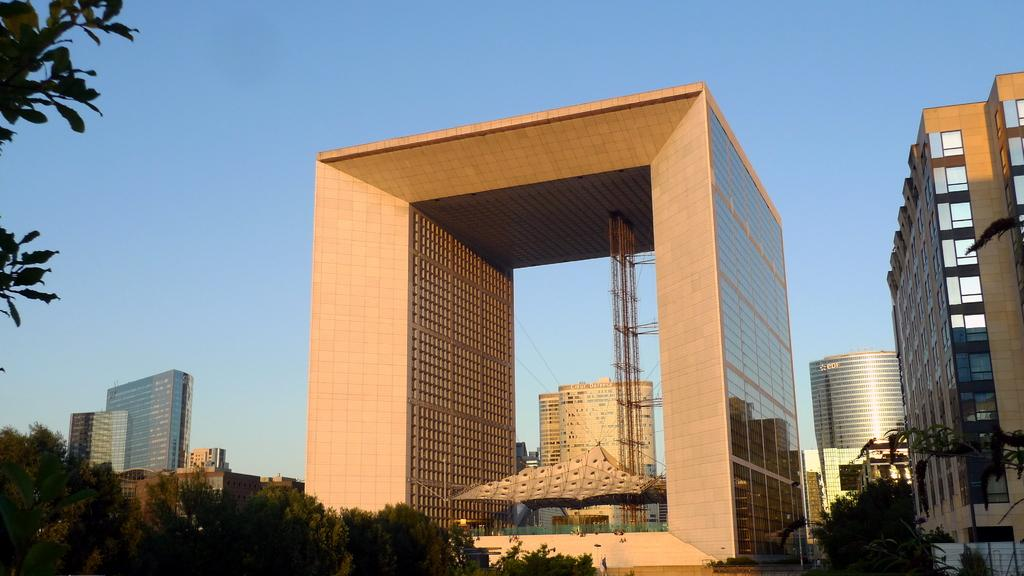What can be seen on the left side of the image? There are trees and buildings on the left side of the image. What is present in the foreground of the image? There are buildings, trees, and objects in the foreground. What is visible at the top of the image? The sky is visible at the top of the image. Where is the base of the deer located in the image? There is no deer present in the image, so it is not possible to determine the location of its base. What type of box can be seen in the foreground of the image? There is no box present in the image; the foreground contains buildings, trees, and objects. 